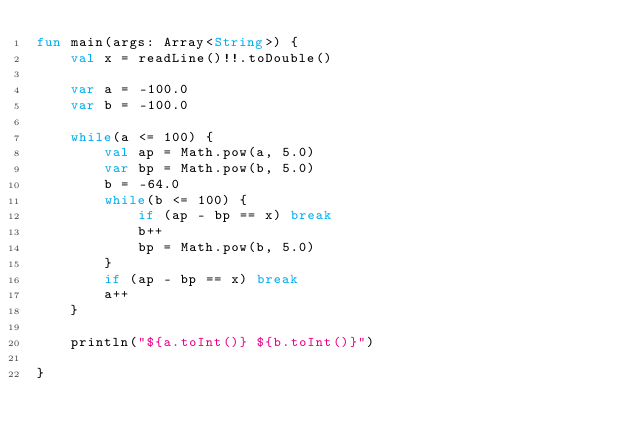<code> <loc_0><loc_0><loc_500><loc_500><_Kotlin_>fun main(args: Array<String>) {
    val x = readLine()!!.toDouble()

    var a = -100.0
    var b = -100.0

    while(a <= 100) {
        val ap = Math.pow(a, 5.0)
        var bp = Math.pow(b, 5.0)
        b = -64.0
        while(b <= 100) {
            if (ap - bp == x) break
            b++
            bp = Math.pow(b, 5.0)
        }
        if (ap - bp == x) break
        a++
    }

    println("${a.toInt()} ${b.toInt()}")

}
</code> 